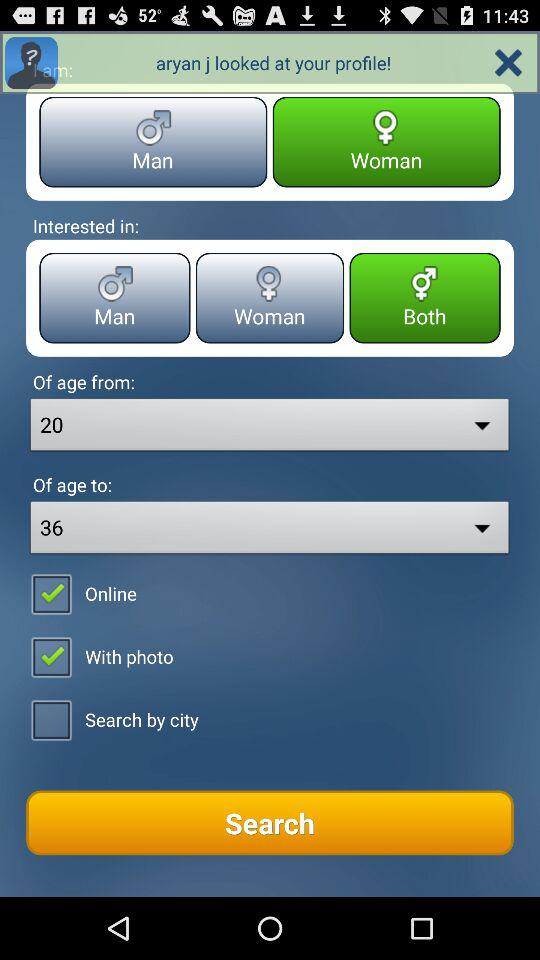How long has the user been online?
When the provided information is insufficient, respond with <no answer>. <no answer> 